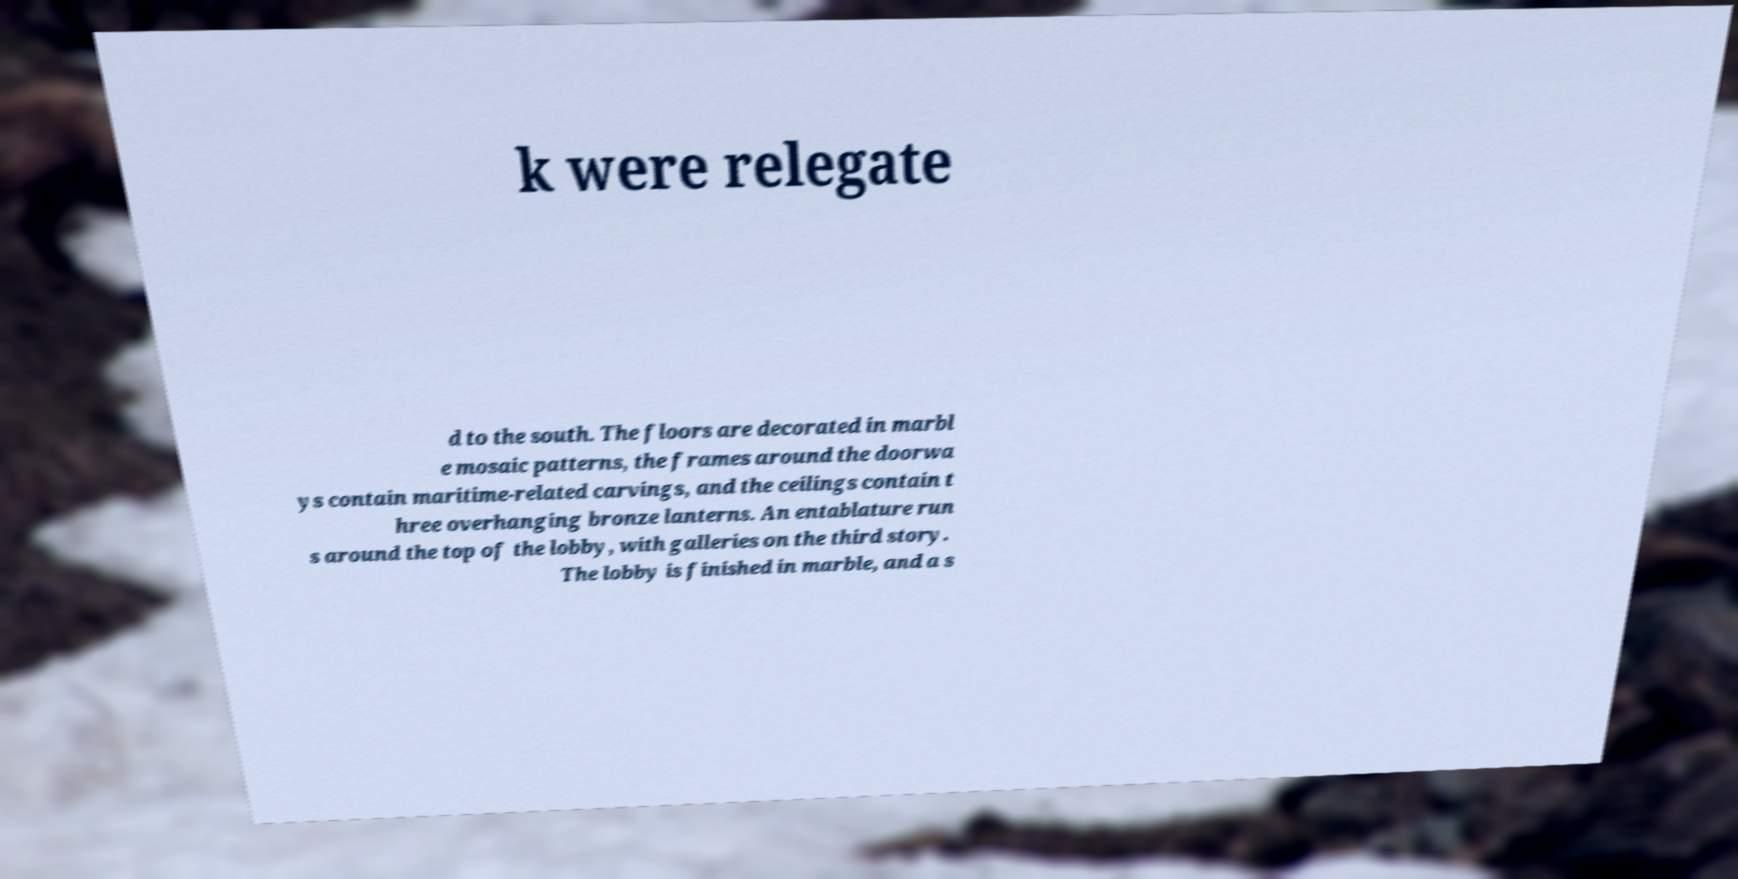I need the written content from this picture converted into text. Can you do that? k were relegate d to the south. The floors are decorated in marbl e mosaic patterns, the frames around the doorwa ys contain maritime-related carvings, and the ceilings contain t hree overhanging bronze lanterns. An entablature run s around the top of the lobby, with galleries on the third story. The lobby is finished in marble, and a s 